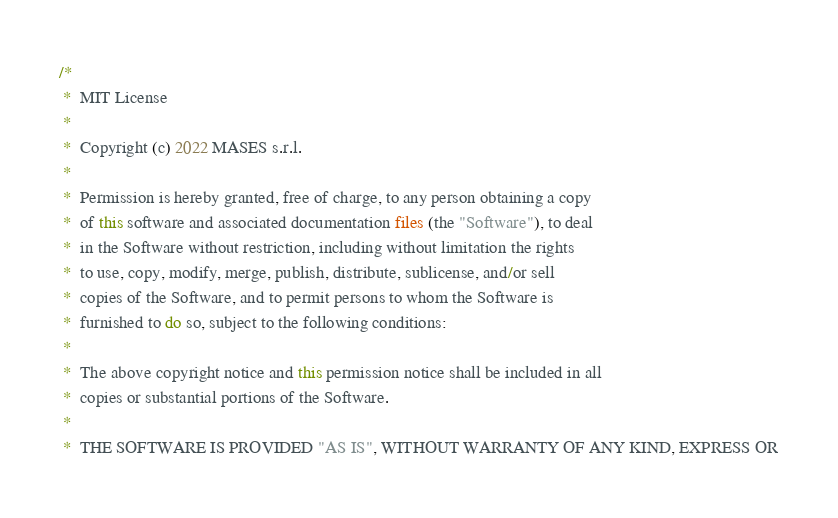Convert code to text. <code><loc_0><loc_0><loc_500><loc_500><_Java_>/*
 *  MIT License
 *
 *  Copyright (c) 2022 MASES s.r.l.
 *
 *  Permission is hereby granted, free of charge, to any person obtaining a copy
 *  of this software and associated documentation files (the "Software"), to deal
 *  in the Software without restriction, including without limitation the rights
 *  to use, copy, modify, merge, publish, distribute, sublicense, and/or sell
 *  copies of the Software, and to permit persons to whom the Software is
 *  furnished to do so, subject to the following conditions:
 *
 *  The above copyright notice and this permission notice shall be included in all
 *  copies or substantial portions of the Software.
 *
 *  THE SOFTWARE IS PROVIDED "AS IS", WITHOUT WARRANTY OF ANY KIND, EXPRESS OR</code> 